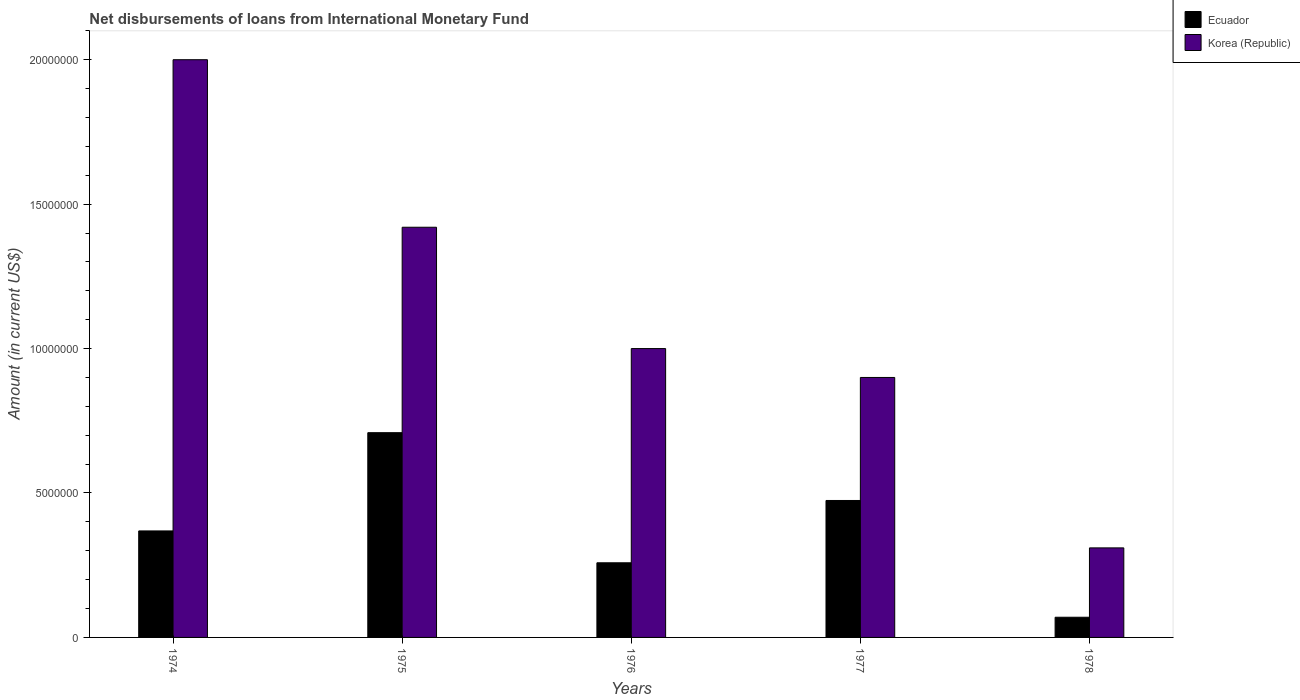How many different coloured bars are there?
Offer a terse response. 2. How many groups of bars are there?
Your answer should be compact. 5. Are the number of bars per tick equal to the number of legend labels?
Provide a succinct answer. Yes. Are the number of bars on each tick of the X-axis equal?
Provide a short and direct response. Yes. What is the label of the 2nd group of bars from the left?
Keep it short and to the point. 1975. What is the amount of loans disbursed in Ecuador in 1976?
Your answer should be very brief. 2.58e+06. Across all years, what is the minimum amount of loans disbursed in Korea (Republic)?
Ensure brevity in your answer.  3.10e+06. In which year was the amount of loans disbursed in Ecuador maximum?
Make the answer very short. 1975. In which year was the amount of loans disbursed in Korea (Republic) minimum?
Ensure brevity in your answer.  1978. What is the total amount of loans disbursed in Ecuador in the graph?
Make the answer very short. 1.88e+07. What is the difference between the amount of loans disbursed in Korea (Republic) in 1975 and that in 1976?
Provide a short and direct response. 4.20e+06. What is the difference between the amount of loans disbursed in Korea (Republic) in 1977 and the amount of loans disbursed in Ecuador in 1975?
Ensure brevity in your answer.  1.91e+06. What is the average amount of loans disbursed in Ecuador per year?
Ensure brevity in your answer.  3.76e+06. In the year 1976, what is the difference between the amount of loans disbursed in Ecuador and amount of loans disbursed in Korea (Republic)?
Keep it short and to the point. -7.42e+06. In how many years, is the amount of loans disbursed in Korea (Republic) greater than 8000000 US$?
Keep it short and to the point. 4. What is the ratio of the amount of loans disbursed in Ecuador in 1974 to that in 1975?
Give a very brief answer. 0.52. Is the difference between the amount of loans disbursed in Ecuador in 1975 and 1976 greater than the difference between the amount of loans disbursed in Korea (Republic) in 1975 and 1976?
Your answer should be very brief. Yes. What is the difference between the highest and the second highest amount of loans disbursed in Ecuador?
Offer a terse response. 2.35e+06. What is the difference between the highest and the lowest amount of loans disbursed in Korea (Republic)?
Offer a terse response. 1.69e+07. In how many years, is the amount of loans disbursed in Korea (Republic) greater than the average amount of loans disbursed in Korea (Republic) taken over all years?
Keep it short and to the point. 2. What does the 2nd bar from the right in 1975 represents?
Ensure brevity in your answer.  Ecuador. How many years are there in the graph?
Your response must be concise. 5. What is the difference between two consecutive major ticks on the Y-axis?
Provide a succinct answer. 5.00e+06. Does the graph contain any zero values?
Provide a short and direct response. No. Does the graph contain grids?
Provide a succinct answer. No. Where does the legend appear in the graph?
Your response must be concise. Top right. How many legend labels are there?
Your answer should be compact. 2. What is the title of the graph?
Offer a very short reply. Net disbursements of loans from International Monetary Fund. What is the label or title of the Y-axis?
Offer a very short reply. Amount (in current US$). What is the Amount (in current US$) in Ecuador in 1974?
Your answer should be very brief. 3.69e+06. What is the Amount (in current US$) in Korea (Republic) in 1974?
Your response must be concise. 2.00e+07. What is the Amount (in current US$) in Ecuador in 1975?
Provide a short and direct response. 7.09e+06. What is the Amount (in current US$) of Korea (Republic) in 1975?
Your answer should be very brief. 1.42e+07. What is the Amount (in current US$) in Ecuador in 1976?
Your answer should be compact. 2.58e+06. What is the Amount (in current US$) of Ecuador in 1977?
Your answer should be compact. 4.74e+06. What is the Amount (in current US$) of Korea (Republic) in 1977?
Your answer should be compact. 9.00e+06. What is the Amount (in current US$) of Ecuador in 1978?
Your answer should be very brief. 6.99e+05. What is the Amount (in current US$) of Korea (Republic) in 1978?
Provide a succinct answer. 3.10e+06. Across all years, what is the maximum Amount (in current US$) of Ecuador?
Your answer should be compact. 7.09e+06. Across all years, what is the minimum Amount (in current US$) in Ecuador?
Keep it short and to the point. 6.99e+05. Across all years, what is the minimum Amount (in current US$) of Korea (Republic)?
Keep it short and to the point. 3.10e+06. What is the total Amount (in current US$) in Ecuador in the graph?
Make the answer very short. 1.88e+07. What is the total Amount (in current US$) in Korea (Republic) in the graph?
Provide a succinct answer. 5.63e+07. What is the difference between the Amount (in current US$) of Ecuador in 1974 and that in 1975?
Your response must be concise. -3.40e+06. What is the difference between the Amount (in current US$) of Korea (Republic) in 1974 and that in 1975?
Keep it short and to the point. 5.80e+06. What is the difference between the Amount (in current US$) of Ecuador in 1974 and that in 1976?
Offer a very short reply. 1.10e+06. What is the difference between the Amount (in current US$) of Korea (Republic) in 1974 and that in 1976?
Keep it short and to the point. 1.00e+07. What is the difference between the Amount (in current US$) in Ecuador in 1974 and that in 1977?
Make the answer very short. -1.05e+06. What is the difference between the Amount (in current US$) of Korea (Republic) in 1974 and that in 1977?
Make the answer very short. 1.10e+07. What is the difference between the Amount (in current US$) in Ecuador in 1974 and that in 1978?
Ensure brevity in your answer.  2.99e+06. What is the difference between the Amount (in current US$) of Korea (Republic) in 1974 and that in 1978?
Ensure brevity in your answer.  1.69e+07. What is the difference between the Amount (in current US$) of Ecuador in 1975 and that in 1976?
Your response must be concise. 4.50e+06. What is the difference between the Amount (in current US$) in Korea (Republic) in 1975 and that in 1976?
Your response must be concise. 4.20e+06. What is the difference between the Amount (in current US$) in Ecuador in 1975 and that in 1977?
Provide a succinct answer. 2.35e+06. What is the difference between the Amount (in current US$) in Korea (Republic) in 1975 and that in 1977?
Keep it short and to the point. 5.20e+06. What is the difference between the Amount (in current US$) of Ecuador in 1975 and that in 1978?
Make the answer very short. 6.39e+06. What is the difference between the Amount (in current US$) in Korea (Republic) in 1975 and that in 1978?
Your response must be concise. 1.11e+07. What is the difference between the Amount (in current US$) in Ecuador in 1976 and that in 1977?
Your answer should be compact. -2.16e+06. What is the difference between the Amount (in current US$) of Ecuador in 1976 and that in 1978?
Provide a short and direct response. 1.88e+06. What is the difference between the Amount (in current US$) in Korea (Republic) in 1976 and that in 1978?
Make the answer very short. 6.90e+06. What is the difference between the Amount (in current US$) of Ecuador in 1977 and that in 1978?
Give a very brief answer. 4.04e+06. What is the difference between the Amount (in current US$) of Korea (Republic) in 1977 and that in 1978?
Your response must be concise. 5.90e+06. What is the difference between the Amount (in current US$) in Ecuador in 1974 and the Amount (in current US$) in Korea (Republic) in 1975?
Keep it short and to the point. -1.05e+07. What is the difference between the Amount (in current US$) in Ecuador in 1974 and the Amount (in current US$) in Korea (Republic) in 1976?
Provide a short and direct response. -6.31e+06. What is the difference between the Amount (in current US$) in Ecuador in 1974 and the Amount (in current US$) in Korea (Republic) in 1977?
Make the answer very short. -5.31e+06. What is the difference between the Amount (in current US$) of Ecuador in 1974 and the Amount (in current US$) of Korea (Republic) in 1978?
Provide a short and direct response. 5.87e+05. What is the difference between the Amount (in current US$) in Ecuador in 1975 and the Amount (in current US$) in Korea (Republic) in 1976?
Your answer should be compact. -2.91e+06. What is the difference between the Amount (in current US$) of Ecuador in 1975 and the Amount (in current US$) of Korea (Republic) in 1977?
Offer a very short reply. -1.91e+06. What is the difference between the Amount (in current US$) in Ecuador in 1975 and the Amount (in current US$) in Korea (Republic) in 1978?
Keep it short and to the point. 3.99e+06. What is the difference between the Amount (in current US$) of Ecuador in 1976 and the Amount (in current US$) of Korea (Republic) in 1977?
Your response must be concise. -6.42e+06. What is the difference between the Amount (in current US$) in Ecuador in 1976 and the Amount (in current US$) in Korea (Republic) in 1978?
Ensure brevity in your answer.  -5.16e+05. What is the difference between the Amount (in current US$) in Ecuador in 1977 and the Amount (in current US$) in Korea (Republic) in 1978?
Offer a very short reply. 1.64e+06. What is the average Amount (in current US$) in Ecuador per year?
Offer a terse response. 3.76e+06. What is the average Amount (in current US$) in Korea (Republic) per year?
Keep it short and to the point. 1.13e+07. In the year 1974, what is the difference between the Amount (in current US$) of Ecuador and Amount (in current US$) of Korea (Republic)?
Your answer should be compact. -1.63e+07. In the year 1975, what is the difference between the Amount (in current US$) of Ecuador and Amount (in current US$) of Korea (Republic)?
Offer a very short reply. -7.11e+06. In the year 1976, what is the difference between the Amount (in current US$) in Ecuador and Amount (in current US$) in Korea (Republic)?
Your answer should be compact. -7.42e+06. In the year 1977, what is the difference between the Amount (in current US$) of Ecuador and Amount (in current US$) of Korea (Republic)?
Give a very brief answer. -4.26e+06. In the year 1978, what is the difference between the Amount (in current US$) in Ecuador and Amount (in current US$) in Korea (Republic)?
Provide a succinct answer. -2.40e+06. What is the ratio of the Amount (in current US$) of Ecuador in 1974 to that in 1975?
Give a very brief answer. 0.52. What is the ratio of the Amount (in current US$) of Korea (Republic) in 1974 to that in 1975?
Offer a terse response. 1.41. What is the ratio of the Amount (in current US$) in Ecuador in 1974 to that in 1976?
Your answer should be very brief. 1.43. What is the ratio of the Amount (in current US$) of Ecuador in 1974 to that in 1977?
Your answer should be very brief. 0.78. What is the ratio of the Amount (in current US$) in Korea (Republic) in 1974 to that in 1977?
Your answer should be compact. 2.22. What is the ratio of the Amount (in current US$) of Ecuador in 1974 to that in 1978?
Give a very brief answer. 5.27. What is the ratio of the Amount (in current US$) in Korea (Republic) in 1974 to that in 1978?
Ensure brevity in your answer.  6.45. What is the ratio of the Amount (in current US$) of Ecuador in 1975 to that in 1976?
Your response must be concise. 2.74. What is the ratio of the Amount (in current US$) of Korea (Republic) in 1975 to that in 1976?
Offer a very short reply. 1.42. What is the ratio of the Amount (in current US$) in Ecuador in 1975 to that in 1977?
Give a very brief answer. 1.5. What is the ratio of the Amount (in current US$) in Korea (Republic) in 1975 to that in 1977?
Provide a succinct answer. 1.58. What is the ratio of the Amount (in current US$) in Ecuador in 1975 to that in 1978?
Offer a terse response. 10.14. What is the ratio of the Amount (in current US$) of Korea (Republic) in 1975 to that in 1978?
Provide a short and direct response. 4.58. What is the ratio of the Amount (in current US$) of Ecuador in 1976 to that in 1977?
Keep it short and to the point. 0.55. What is the ratio of the Amount (in current US$) in Ecuador in 1976 to that in 1978?
Ensure brevity in your answer.  3.7. What is the ratio of the Amount (in current US$) in Korea (Republic) in 1976 to that in 1978?
Give a very brief answer. 3.23. What is the ratio of the Amount (in current US$) of Ecuador in 1977 to that in 1978?
Offer a terse response. 6.78. What is the ratio of the Amount (in current US$) of Korea (Republic) in 1977 to that in 1978?
Provide a short and direct response. 2.9. What is the difference between the highest and the second highest Amount (in current US$) of Ecuador?
Ensure brevity in your answer.  2.35e+06. What is the difference between the highest and the second highest Amount (in current US$) in Korea (Republic)?
Make the answer very short. 5.80e+06. What is the difference between the highest and the lowest Amount (in current US$) in Ecuador?
Keep it short and to the point. 6.39e+06. What is the difference between the highest and the lowest Amount (in current US$) of Korea (Republic)?
Give a very brief answer. 1.69e+07. 